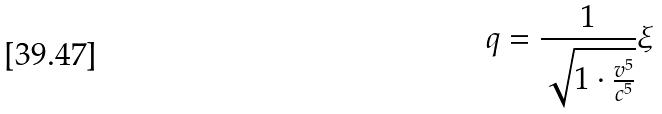Convert formula to latex. <formula><loc_0><loc_0><loc_500><loc_500>q = \frac { 1 } { \sqrt { 1 \cdot \frac { v ^ { 5 } } { c ^ { 5 } } } } \xi</formula> 